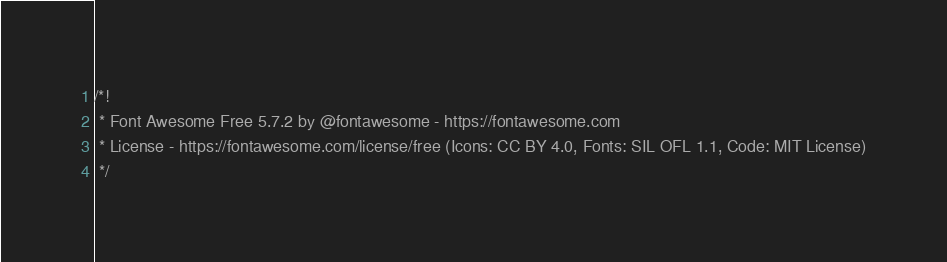<code> <loc_0><loc_0><loc_500><loc_500><_CSS_>/*!
 * Font Awesome Free 5.7.2 by @fontawesome - https://fontawesome.com
 * License - https://fontawesome.com/license/free (Icons: CC BY 4.0, Fonts: SIL OFL 1.1, Code: MIT License)
 */</code> 